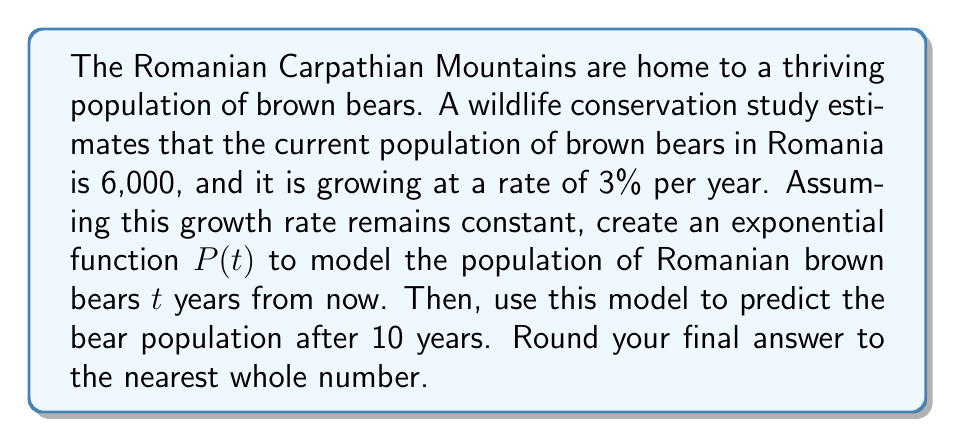Can you answer this question? To model the population growth of Romanian brown bears using an exponential function, we'll follow these steps:

1) The general form of an exponential growth function is:
   $P(t) = P_0 \cdot (1 + r)^t$
   where $P_0$ is the initial population, $r$ is the growth rate, and $t$ is the time in years.

2) From the given information:
   $P_0 = 6,000$ (initial population)
   $r = 0.03$ (3% growth rate expressed as a decimal)

3) Substituting these values into the general form:
   $P(t) = 6000 \cdot (1 + 0.03)^t$

4) Simplifying:
   $P(t) = 6000 \cdot (1.03)^t$

This is our exponential function modeling the brown bear population growth.

5) To predict the population after 10 years, we substitute $t = 10$:
   $P(10) = 6000 \cdot (1.03)^{10}$

6) Calculating:
   $P(10) = 6000 \cdot 1.3439$
   $P(10) = 8,063.4$

7) Rounding to the nearest whole number:
   $P(10) \approx 8,063$ bears
Answer: The exponential function modeling the Romanian brown bear population growth is:
$P(t) = 6000 \cdot (1.03)^t$

After 10 years, the predicted population will be approximately 8,063 bears. 